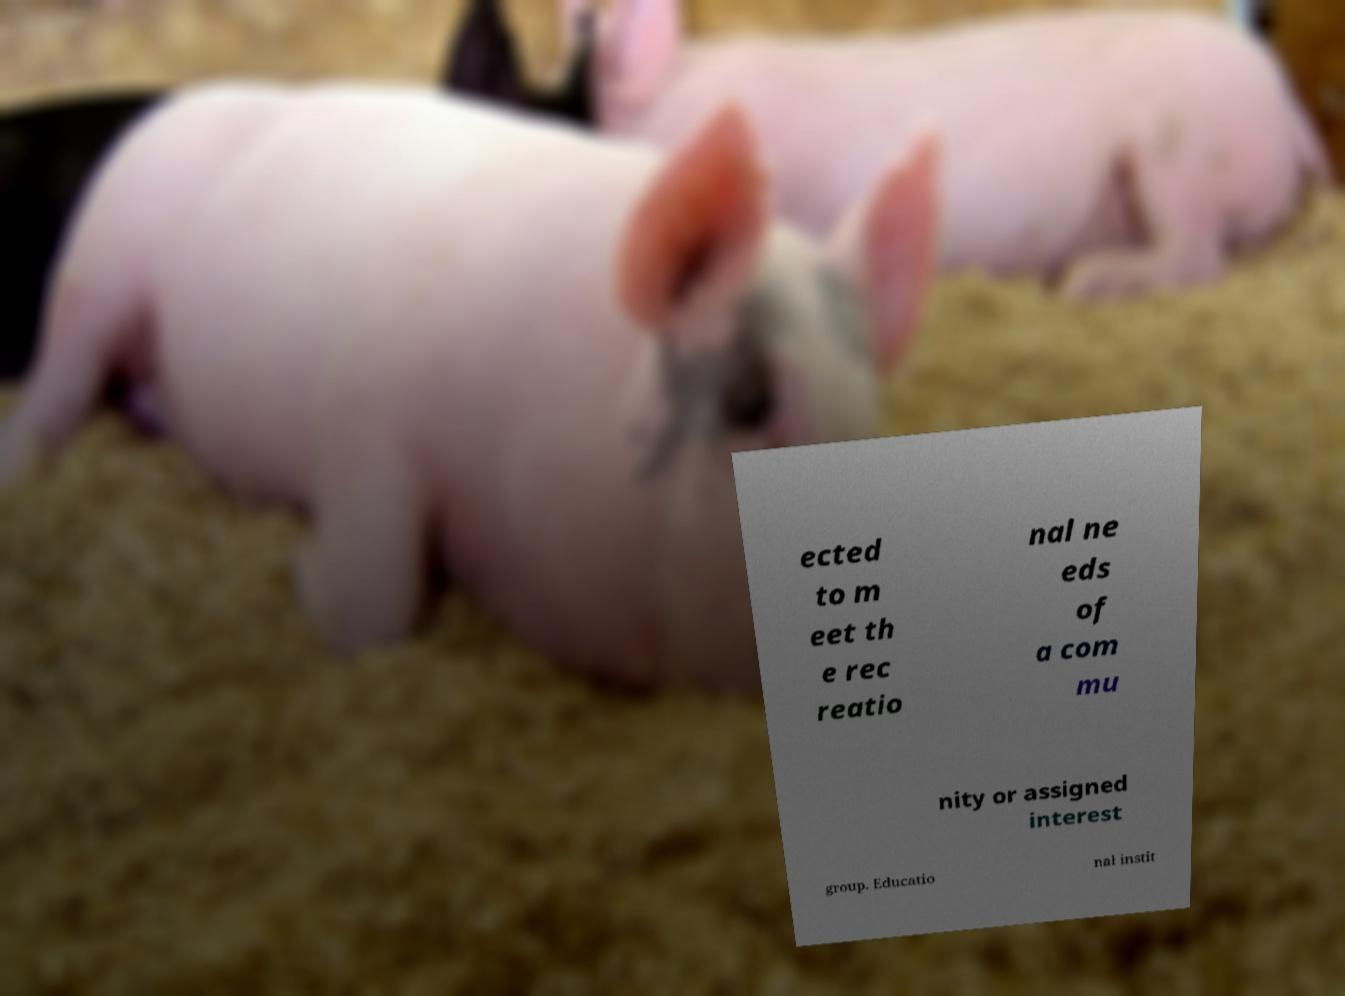There's text embedded in this image that I need extracted. Can you transcribe it verbatim? ected to m eet th e rec reatio nal ne eds of a com mu nity or assigned interest group. Educatio nal instit 